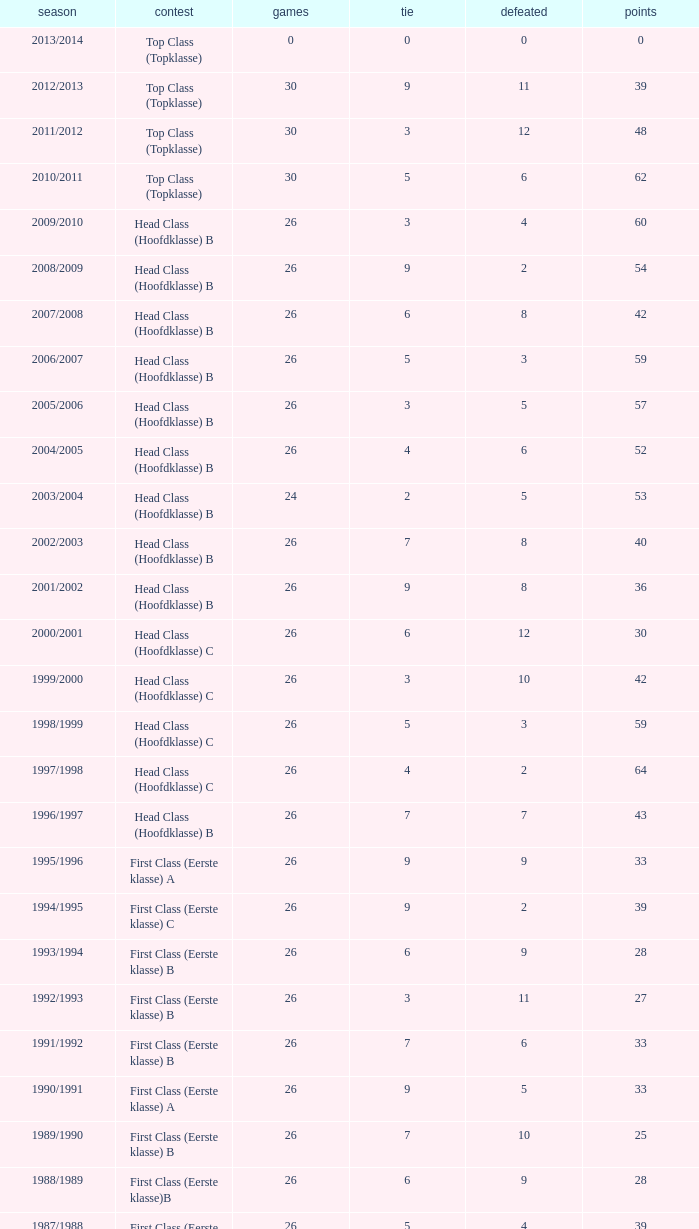What is the sum of the losses that a match score larger than 26, a points score of 62, and a draw greater than 5? None. 